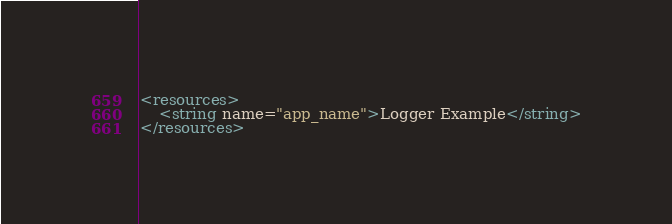<code> <loc_0><loc_0><loc_500><loc_500><_XML_><resources>
	<string name="app_name">Logger Example</string>
</resources>
</code> 